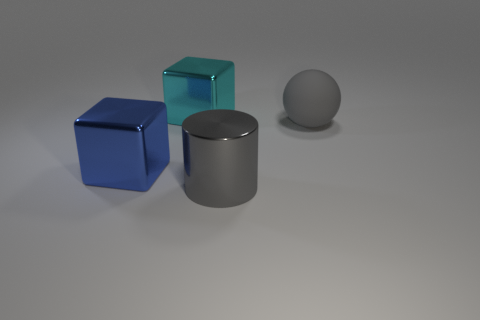There is a cylinder in front of the blue metallic block; does it have the same color as the ball?
Offer a very short reply. Yes. What number of rubber balls have the same color as the big shiny cylinder?
Provide a succinct answer. 1. What material is the large object that is the same color as the cylinder?
Offer a terse response. Rubber. Are there any cyan objects that have the same material as the cyan block?
Your answer should be compact. No. There is a blue cube that is the same size as the cyan shiny thing; what is its material?
Make the answer very short. Metal. Does the big shiny cylinder in front of the large gray rubber thing have the same color as the big thing on the right side of the gray metallic cylinder?
Your answer should be very brief. Yes. There is a gray thing that is to the right of the gray metallic thing; are there any large gray metallic cylinders behind it?
Your response must be concise. No. Do the gray thing in front of the big gray matte sphere and the big object right of the large gray metallic cylinder have the same shape?
Make the answer very short. No. Does the big gray thing that is left of the big gray matte sphere have the same material as the large cube that is behind the big gray ball?
Your answer should be compact. Yes. The block left of the large shiny thing that is behind the big gray matte object is made of what material?
Your answer should be very brief. Metal. 